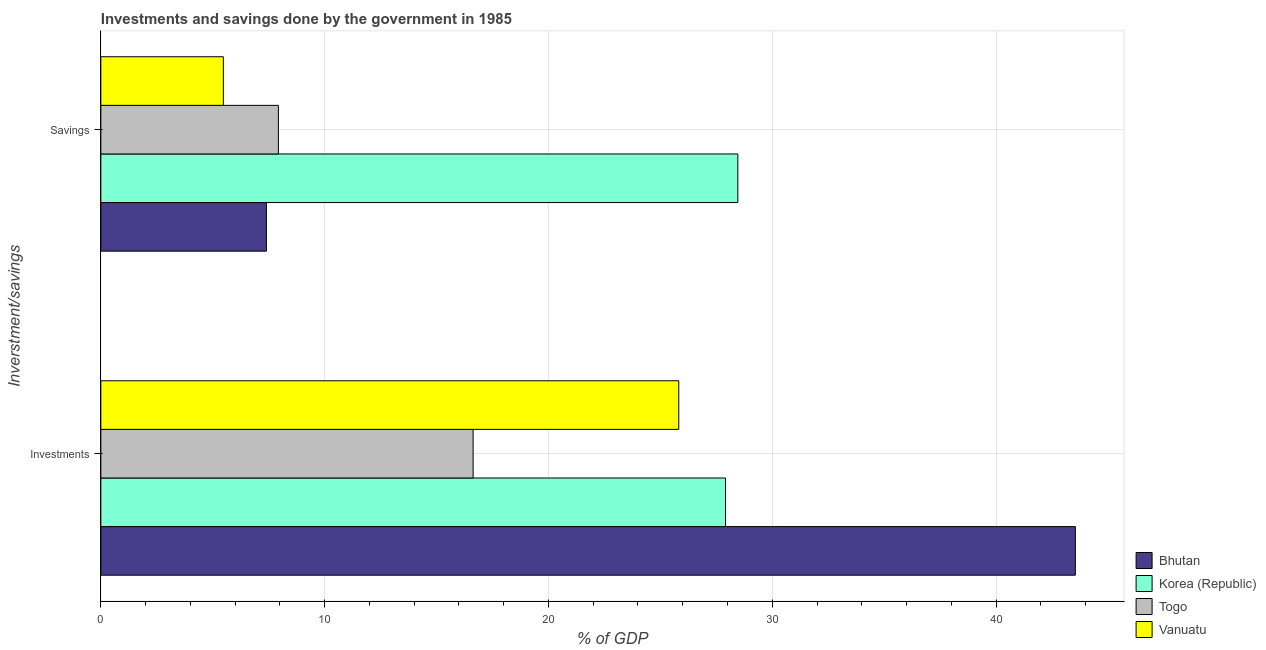How many different coloured bars are there?
Give a very brief answer. 4. Are the number of bars per tick equal to the number of legend labels?
Ensure brevity in your answer.  Yes. Are the number of bars on each tick of the Y-axis equal?
Your answer should be compact. Yes. How many bars are there on the 2nd tick from the bottom?
Offer a very short reply. 4. What is the label of the 2nd group of bars from the top?
Your answer should be compact. Investments. What is the savings of government in Togo?
Your response must be concise. 7.93. Across all countries, what is the maximum savings of government?
Your answer should be very brief. 28.46. Across all countries, what is the minimum investments of government?
Give a very brief answer. 16.63. In which country was the investments of government maximum?
Your answer should be compact. Bhutan. In which country was the investments of government minimum?
Offer a very short reply. Togo. What is the total savings of government in the graph?
Make the answer very short. 49.27. What is the difference between the savings of government in Korea (Republic) and that in Togo?
Your answer should be compact. 20.53. What is the difference between the savings of government in Togo and the investments of government in Bhutan?
Your answer should be very brief. -35.61. What is the average savings of government per country?
Keep it short and to the point. 12.32. What is the difference between the savings of government and investments of government in Bhutan?
Your answer should be compact. -36.14. In how many countries, is the savings of government greater than 20 %?
Provide a short and direct response. 1. What is the ratio of the investments of government in Vanuatu to that in Togo?
Make the answer very short. 1.55. In how many countries, is the investments of government greater than the average investments of government taken over all countries?
Your answer should be very brief. 1. What does the 3rd bar from the top in Investments represents?
Your answer should be very brief. Korea (Republic). Are all the bars in the graph horizontal?
Provide a succinct answer. Yes. What is the difference between two consecutive major ticks on the X-axis?
Keep it short and to the point. 10. Are the values on the major ticks of X-axis written in scientific E-notation?
Make the answer very short. No. Does the graph contain any zero values?
Your answer should be compact. No. Does the graph contain grids?
Your answer should be very brief. Yes. What is the title of the graph?
Your answer should be very brief. Investments and savings done by the government in 1985. What is the label or title of the X-axis?
Your response must be concise. % of GDP. What is the label or title of the Y-axis?
Make the answer very short. Inverstment/savings. What is the % of GDP of Bhutan in Investments?
Give a very brief answer. 43.54. What is the % of GDP in Korea (Republic) in Investments?
Provide a short and direct response. 27.91. What is the % of GDP of Togo in Investments?
Keep it short and to the point. 16.63. What is the % of GDP of Vanuatu in Investments?
Your answer should be compact. 25.82. What is the % of GDP of Bhutan in Savings?
Keep it short and to the point. 7.4. What is the % of GDP of Korea (Republic) in Savings?
Provide a succinct answer. 28.46. What is the % of GDP of Togo in Savings?
Offer a terse response. 7.93. What is the % of GDP of Vanuatu in Savings?
Keep it short and to the point. 5.47. Across all Inverstment/savings, what is the maximum % of GDP in Bhutan?
Ensure brevity in your answer.  43.54. Across all Inverstment/savings, what is the maximum % of GDP of Korea (Republic)?
Offer a terse response. 28.46. Across all Inverstment/savings, what is the maximum % of GDP of Togo?
Keep it short and to the point. 16.63. Across all Inverstment/savings, what is the maximum % of GDP in Vanuatu?
Your response must be concise. 25.82. Across all Inverstment/savings, what is the minimum % of GDP of Bhutan?
Provide a short and direct response. 7.4. Across all Inverstment/savings, what is the minimum % of GDP of Korea (Republic)?
Your answer should be very brief. 27.91. Across all Inverstment/savings, what is the minimum % of GDP in Togo?
Provide a short and direct response. 7.93. Across all Inverstment/savings, what is the minimum % of GDP of Vanuatu?
Offer a terse response. 5.47. What is the total % of GDP in Bhutan in the graph?
Offer a terse response. 50.94. What is the total % of GDP in Korea (Republic) in the graph?
Provide a succinct answer. 56.37. What is the total % of GDP of Togo in the graph?
Offer a very short reply. 24.57. What is the total % of GDP of Vanuatu in the graph?
Keep it short and to the point. 31.3. What is the difference between the % of GDP in Bhutan in Investments and that in Savings?
Offer a terse response. 36.14. What is the difference between the % of GDP of Korea (Republic) in Investments and that in Savings?
Your answer should be very brief. -0.55. What is the difference between the % of GDP in Togo in Investments and that in Savings?
Offer a terse response. 8.7. What is the difference between the % of GDP of Vanuatu in Investments and that in Savings?
Ensure brevity in your answer.  20.35. What is the difference between the % of GDP of Bhutan in Investments and the % of GDP of Korea (Republic) in Savings?
Offer a terse response. 15.08. What is the difference between the % of GDP of Bhutan in Investments and the % of GDP of Togo in Savings?
Give a very brief answer. 35.61. What is the difference between the % of GDP of Bhutan in Investments and the % of GDP of Vanuatu in Savings?
Your response must be concise. 38.07. What is the difference between the % of GDP in Korea (Republic) in Investments and the % of GDP in Togo in Savings?
Provide a succinct answer. 19.98. What is the difference between the % of GDP in Korea (Republic) in Investments and the % of GDP in Vanuatu in Savings?
Give a very brief answer. 22.44. What is the difference between the % of GDP of Togo in Investments and the % of GDP of Vanuatu in Savings?
Offer a very short reply. 11.16. What is the average % of GDP of Bhutan per Inverstment/savings?
Your answer should be very brief. 25.47. What is the average % of GDP in Korea (Republic) per Inverstment/savings?
Your response must be concise. 28.19. What is the average % of GDP of Togo per Inverstment/savings?
Your answer should be compact. 12.28. What is the average % of GDP in Vanuatu per Inverstment/savings?
Offer a very short reply. 15.65. What is the difference between the % of GDP in Bhutan and % of GDP in Korea (Republic) in Investments?
Your answer should be compact. 15.63. What is the difference between the % of GDP in Bhutan and % of GDP in Togo in Investments?
Make the answer very short. 26.91. What is the difference between the % of GDP in Bhutan and % of GDP in Vanuatu in Investments?
Make the answer very short. 17.72. What is the difference between the % of GDP of Korea (Republic) and % of GDP of Togo in Investments?
Your response must be concise. 11.28. What is the difference between the % of GDP in Korea (Republic) and % of GDP in Vanuatu in Investments?
Your answer should be very brief. 2.09. What is the difference between the % of GDP of Togo and % of GDP of Vanuatu in Investments?
Your answer should be compact. -9.19. What is the difference between the % of GDP in Bhutan and % of GDP in Korea (Republic) in Savings?
Make the answer very short. -21.06. What is the difference between the % of GDP in Bhutan and % of GDP in Togo in Savings?
Give a very brief answer. -0.53. What is the difference between the % of GDP in Bhutan and % of GDP in Vanuatu in Savings?
Provide a short and direct response. 1.92. What is the difference between the % of GDP of Korea (Republic) and % of GDP of Togo in Savings?
Give a very brief answer. 20.53. What is the difference between the % of GDP in Korea (Republic) and % of GDP in Vanuatu in Savings?
Your response must be concise. 22.99. What is the difference between the % of GDP of Togo and % of GDP of Vanuatu in Savings?
Keep it short and to the point. 2.46. What is the ratio of the % of GDP in Bhutan in Investments to that in Savings?
Offer a terse response. 5.89. What is the ratio of the % of GDP in Korea (Republic) in Investments to that in Savings?
Your answer should be compact. 0.98. What is the ratio of the % of GDP of Togo in Investments to that in Savings?
Make the answer very short. 2.1. What is the ratio of the % of GDP of Vanuatu in Investments to that in Savings?
Keep it short and to the point. 4.72. What is the difference between the highest and the second highest % of GDP of Bhutan?
Your answer should be compact. 36.14. What is the difference between the highest and the second highest % of GDP in Korea (Republic)?
Ensure brevity in your answer.  0.55. What is the difference between the highest and the second highest % of GDP of Togo?
Your answer should be compact. 8.7. What is the difference between the highest and the second highest % of GDP of Vanuatu?
Your response must be concise. 20.35. What is the difference between the highest and the lowest % of GDP of Bhutan?
Offer a very short reply. 36.14. What is the difference between the highest and the lowest % of GDP of Korea (Republic)?
Offer a terse response. 0.55. What is the difference between the highest and the lowest % of GDP of Togo?
Offer a terse response. 8.7. What is the difference between the highest and the lowest % of GDP of Vanuatu?
Provide a short and direct response. 20.35. 